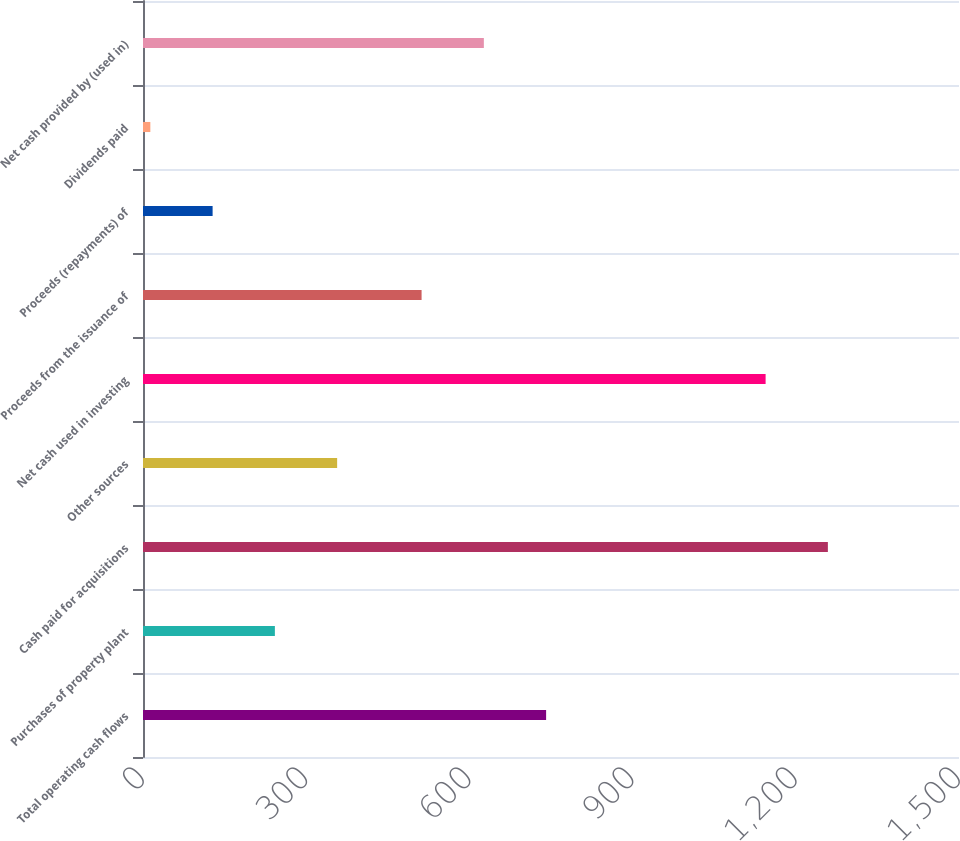Convert chart. <chart><loc_0><loc_0><loc_500><loc_500><bar_chart><fcel>Total operating cash flows<fcel>Purchases of property plant<fcel>Cash paid for acquisitions<fcel>Other sources<fcel>Net cash used in investing<fcel>Proceeds from the issuance of<fcel>Proceeds (repayments) of<fcel>Dividends paid<fcel>Net cash provided by (used in)<nl><fcel>741.02<fcel>242.42<fcel>1258.96<fcel>356.88<fcel>1144.5<fcel>512.1<fcel>127.96<fcel>13.5<fcel>626.56<nl></chart> 